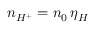Convert formula to latex. <formula><loc_0><loc_0><loc_500><loc_500>n _ { H ^ { + } } = n _ { 0 } \, \eta _ { H }</formula> 